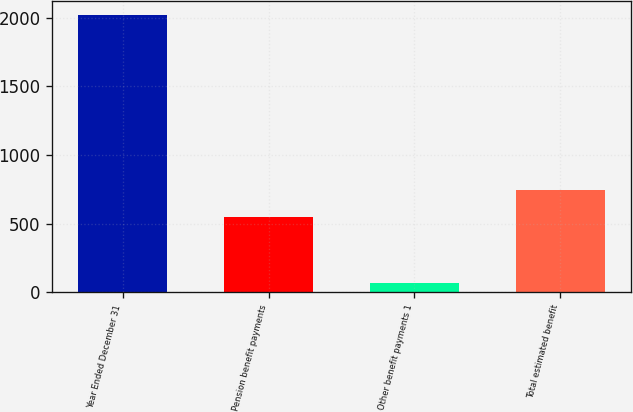<chart> <loc_0><loc_0><loc_500><loc_500><bar_chart><fcel>Year Ended December 31<fcel>Pension benefit payments<fcel>Other benefit payments 1<fcel>Total estimated benefit<nl><fcel>2021<fcel>549<fcel>67<fcel>744.4<nl></chart> 